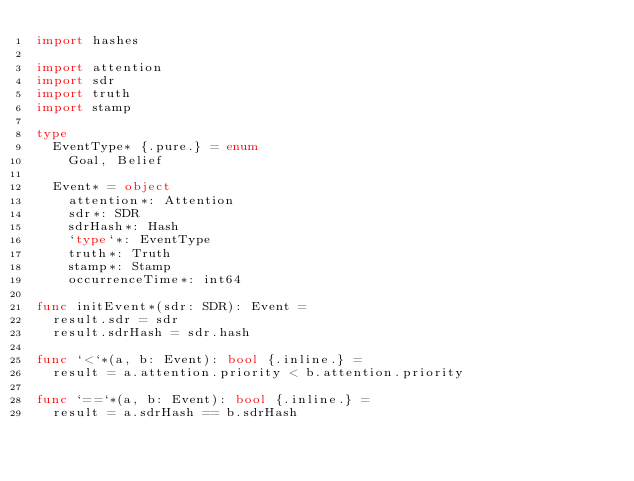Convert code to text. <code><loc_0><loc_0><loc_500><loc_500><_Nim_>import hashes

import attention
import sdr
import truth
import stamp

type
  EventType* {.pure.} = enum
    Goal, Belief

  Event* = object
    attention*: Attention
    sdr*: SDR
    sdrHash*: Hash
    `type`*: EventType
    truth*: Truth
    stamp*: Stamp
    occurrenceTime*: int64

func initEvent*(sdr: SDR): Event =
  result.sdr = sdr
  result.sdrHash = sdr.hash

func `<`*(a, b: Event): bool {.inline.} =
  result = a.attention.priority < b.attention.priority

func `==`*(a, b: Event): bool {.inline.} =
  result = a.sdrHash == b.sdrHash
</code> 